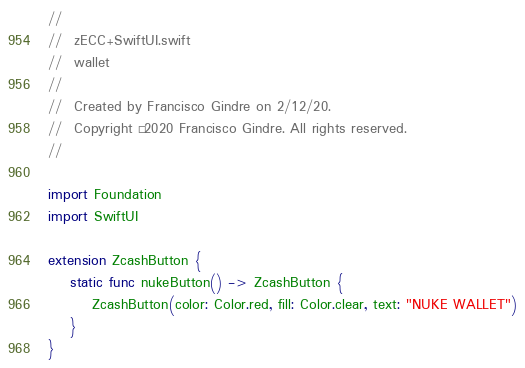<code> <loc_0><loc_0><loc_500><loc_500><_Swift_>//
//  zECC+SwiftUI.swift
//  wallet
//
//  Created by Francisco Gindre on 2/12/20.
//  Copyright © 2020 Francisco Gindre. All rights reserved.
//

import Foundation
import SwiftUI

extension ZcashButton {
    static func nukeButton() -> ZcashButton {
        ZcashButton(color: Color.red, fill: Color.clear, text: "NUKE WALLET")
    }
}
</code> 